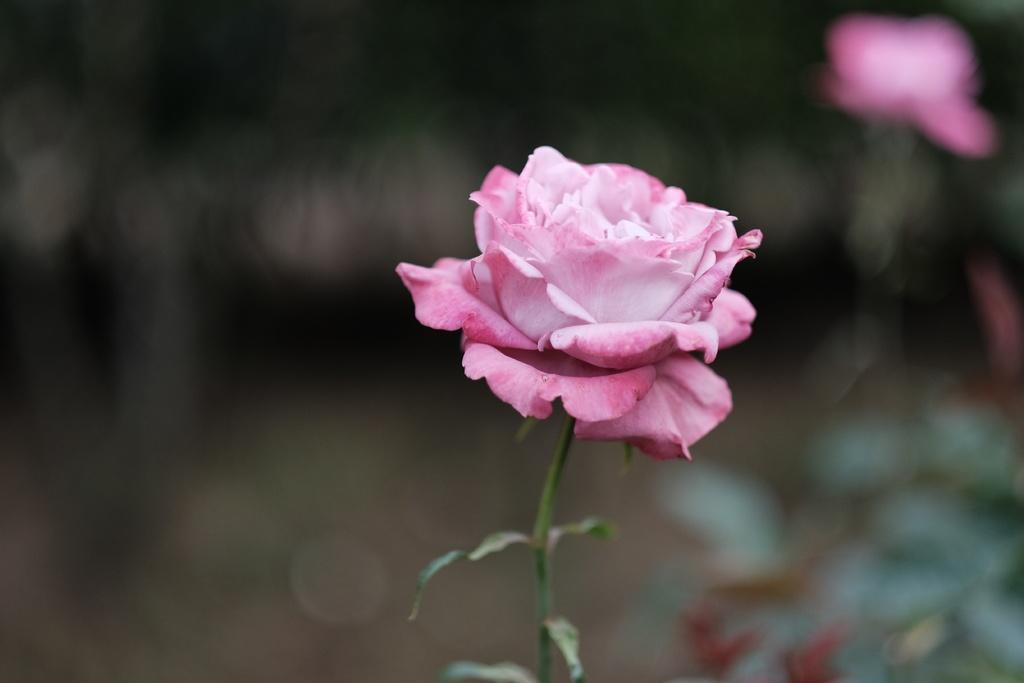What type of flower is in the image? There is a pink rose flower in the image. What else can be seen in the image besides the pink rose flower? There are leaves and another flower on the right side of the image. How would you describe the background of the image? The background of the image is blurred. What type of cracker is visible in the image? There is no cracker present in the image. Can you see the moon in the background of the image? The moon is not visible in the image; the background is blurred. 